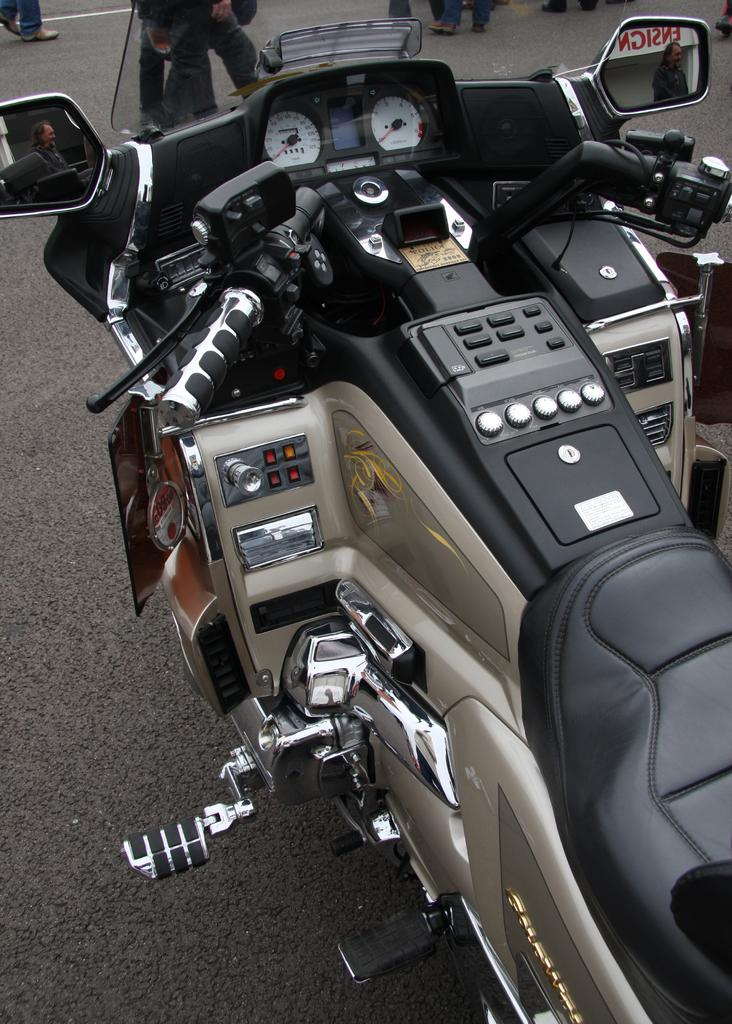What is the main object in the image? There is a bike in the image. Where is the bike located? The bike is on the road. What feature does the bike have? The bike has side mirrors. What can be seen through the side mirrors? People are visible through the side mirrors. What else can be seen in the background of the image? Person's legs are present in the background of the image. What type of shock can be seen on the laborer's face in the image? There is no laborer present in the image, and therefore no shock can be observed on their face. 